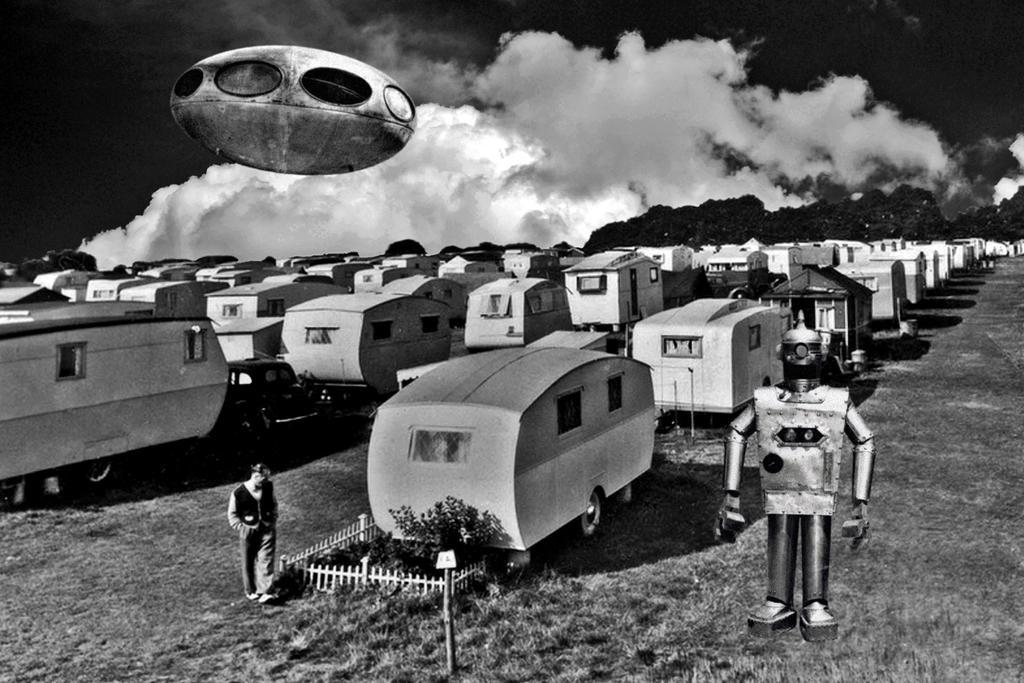Describe this image in one or two sentences. In this picture we can see a spaceship, few houses and a plant. We can see some fencing around a plant. There is a board on the pole. We can see a person and a robot. Sky is cloudy. 